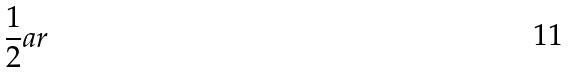<formula> <loc_0><loc_0><loc_500><loc_500>\frac { 1 } { 2 } a r</formula> 